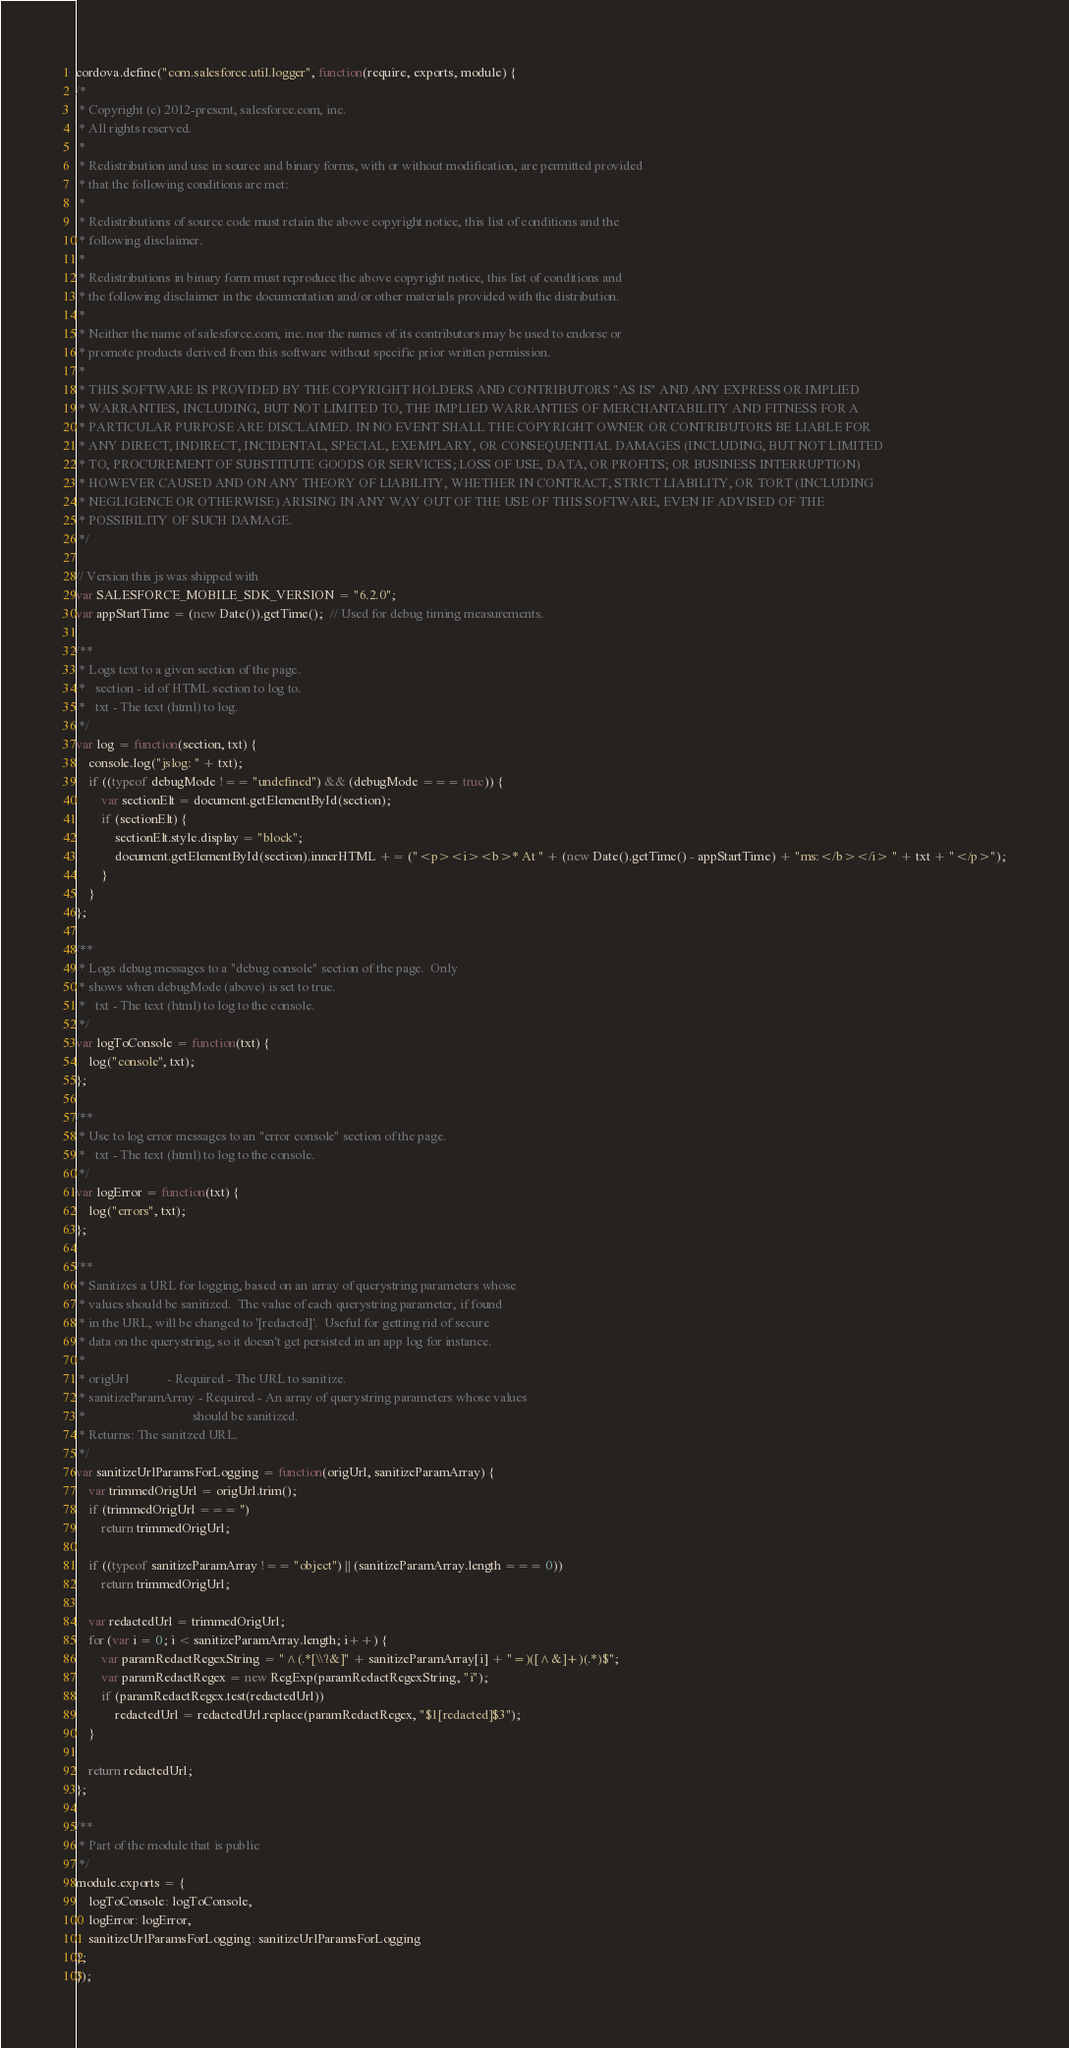<code> <loc_0><loc_0><loc_500><loc_500><_JavaScript_>cordova.define("com.salesforce.util.logger", function(require, exports, module) {
/*
 * Copyright (c) 2012-present, salesforce.com, inc.
 * All rights reserved.
 *
 * Redistribution and use in source and binary forms, with or without modification, are permitted provided
 * that the following conditions are met:
 *
 * Redistributions of source code must retain the above copyright notice, this list of conditions and the
 * following disclaimer.
 *
 * Redistributions in binary form must reproduce the above copyright notice, this list of conditions and
 * the following disclaimer in the documentation and/or other materials provided with the distribution.
 *
 * Neither the name of salesforce.com, inc. nor the names of its contributors may be used to endorse or
 * promote products derived from this software without specific prior written permission.
 *
 * THIS SOFTWARE IS PROVIDED BY THE COPYRIGHT HOLDERS AND CONTRIBUTORS "AS IS" AND ANY EXPRESS OR IMPLIED
 * WARRANTIES, INCLUDING, BUT NOT LIMITED TO, THE IMPLIED WARRANTIES OF MERCHANTABILITY AND FITNESS FOR A
 * PARTICULAR PURPOSE ARE DISCLAIMED. IN NO EVENT SHALL THE COPYRIGHT OWNER OR CONTRIBUTORS BE LIABLE FOR
 * ANY DIRECT, INDIRECT, INCIDENTAL, SPECIAL, EXEMPLARY, OR CONSEQUENTIAL DAMAGES (INCLUDING, BUT NOT LIMITED
 * TO, PROCUREMENT OF SUBSTITUTE GOODS OR SERVICES; LOSS OF USE, DATA, OR PROFITS; OR BUSINESS INTERRUPTION)
 * HOWEVER CAUSED AND ON ANY THEORY OF LIABILITY, WHETHER IN CONTRACT, STRICT LIABILITY, OR TORT (INCLUDING
 * NEGLIGENCE OR OTHERWISE) ARISING IN ANY WAY OUT OF THE USE OF THIS SOFTWARE, EVEN IF ADVISED OF THE
 * POSSIBILITY OF SUCH DAMAGE.
 */

// Version this js was shipped with
var SALESFORCE_MOBILE_SDK_VERSION = "6.2.0";
var appStartTime = (new Date()).getTime();  // Used for debug timing measurements.

/**
 * Logs text to a given section of the page.
 *   section - id of HTML section to log to.
 *   txt - The text (html) to log.
 */
var log = function(section, txt) {
    console.log("jslog: " + txt);
    if ((typeof debugMode !== "undefined") && (debugMode === true)) {
        var sectionElt = document.getElementById(section);
        if (sectionElt) {
            sectionElt.style.display = "block";
            document.getElementById(section).innerHTML += ("<p><i><b>* At " + (new Date().getTime() - appStartTime) + "ms:</b></i> " + txt + "</p>");
        }
    }
};

/**
 * Logs debug messages to a "debug console" section of the page.  Only
 * shows when debugMode (above) is set to true.
 *   txt - The text (html) to log to the console.
 */
var logToConsole = function(txt) {
    log("console", txt);
};

/**
 * Use to log error messages to an "error console" section of the page.
 *   txt - The text (html) to log to the console.
 */
var logError = function(txt) {
    log("errors", txt);
};

/**
 * Sanitizes a URL for logging, based on an array of querystring parameters whose
 * values should be sanitized.  The value of each querystring parameter, if found
 * in the URL, will be changed to '[redacted]'.  Useful for getting rid of secure
 * data on the querystring, so it doesn't get persisted in an app log for instance.
 *
 * origUrl            - Required - The URL to sanitize.
 * sanitizeParamArray - Required - An array of querystring parameters whose values
 *                                 should be sanitized.
 * Returns: The sanitzed URL.
 */
var sanitizeUrlParamsForLogging = function(origUrl, sanitizeParamArray) {
    var trimmedOrigUrl = origUrl.trim();
    if (trimmedOrigUrl === '')
        return trimmedOrigUrl;

    if ((typeof sanitizeParamArray !== "object") || (sanitizeParamArray.length === 0))
        return trimmedOrigUrl;

    var redactedUrl = trimmedOrigUrl;
    for (var i = 0; i < sanitizeParamArray.length; i++) {
        var paramRedactRegexString = "^(.*[\\?&]" + sanitizeParamArray[i] + "=)([^&]+)(.*)$";
        var paramRedactRegex = new RegExp(paramRedactRegexString, "i");
        if (paramRedactRegex.test(redactedUrl))
            redactedUrl = redactedUrl.replace(paramRedactRegex, "$1[redacted]$3");
    }

    return redactedUrl;
};

/**
 * Part of the module that is public
 */
module.exports = {
    logToConsole: logToConsole,
    logError: logError,
    sanitizeUrlParamsForLogging: sanitizeUrlParamsForLogging
};
});
</code> 